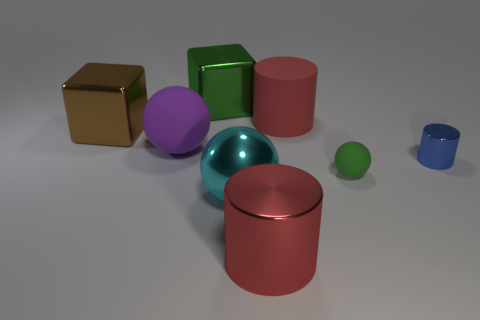There is a red object that is behind the purple rubber ball; what is its material?
Offer a terse response. Rubber. Do the big thing that is behind the big red matte thing and the tiny rubber ball have the same color?
Your answer should be very brief. Yes. What is the shape of the object that is the same color as the big metal cylinder?
Offer a terse response. Cylinder. How many objects are either big red cylinders that are behind the large metal cylinder or tiny brown metal balls?
Provide a succinct answer. 1. Are there any large rubber things of the same shape as the big red shiny thing?
Keep it short and to the point. Yes. What is the shape of the cyan shiny object that is the same size as the purple ball?
Make the answer very short. Sphere. The large shiny object that is on the left side of the matte sphere on the left side of the small object that is left of the blue cylinder is what shape?
Give a very brief answer. Cube. Do the small shiny thing and the large shiny object behind the brown metal object have the same shape?
Provide a short and direct response. No. What number of small things are either purple metal objects or red rubber cylinders?
Your answer should be compact. 0. Is there a red metallic cylinder of the same size as the purple rubber sphere?
Give a very brief answer. Yes. 